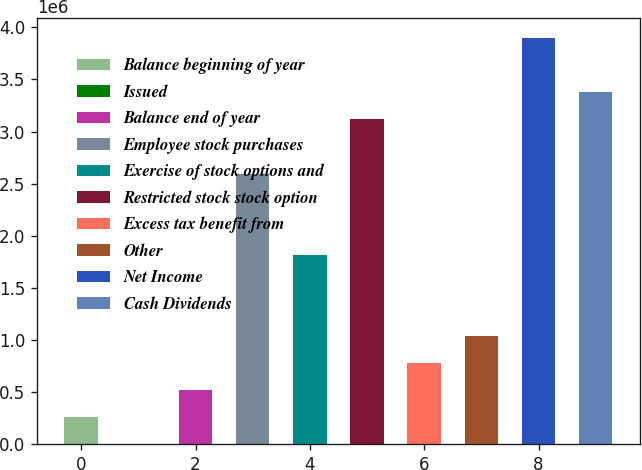<chart> <loc_0><loc_0><loc_500><loc_500><bar_chart><fcel>Balance beginning of year<fcel>Issued<fcel>Balance end of year<fcel>Employee stock purchases<fcel>Exercise of stock options and<fcel>Restricted stock stock option<fcel>Excess tax benefit from<fcel>Other<fcel>Net Income<fcel>Cash Dividends<nl><fcel>259702<fcel>17<fcel>519387<fcel>2.59687e+06<fcel>1.81781e+06<fcel>3.11624e+06<fcel>779072<fcel>1.03876e+06<fcel>3.89529e+06<fcel>3.37592e+06<nl></chart> 